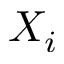<formula> <loc_0><loc_0><loc_500><loc_500>X _ { i }</formula> 